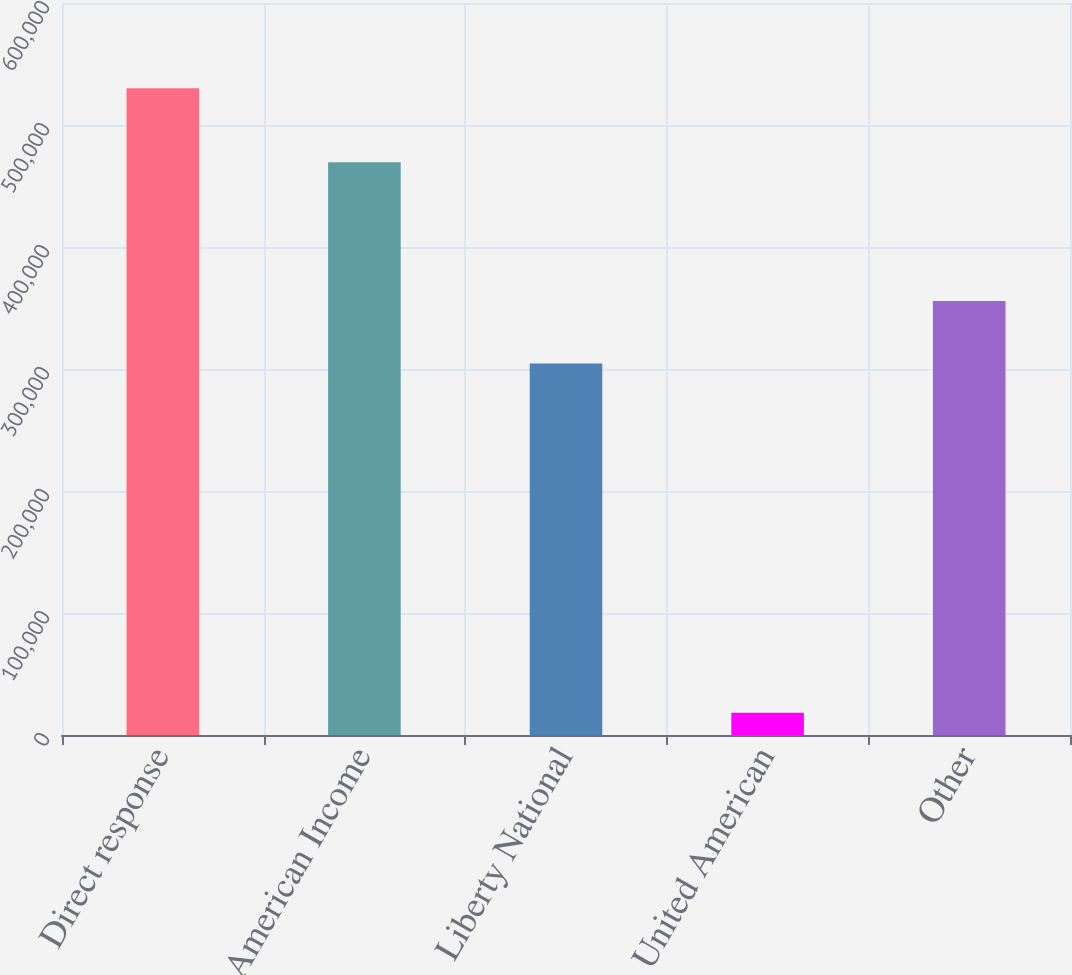<chart> <loc_0><loc_0><loc_500><loc_500><bar_chart><fcel>Direct response<fcel>American Income<fcel>Liberty National<fcel>United American<fcel>Other<nl><fcel>530137<fcel>469486<fcel>304584<fcel>18140<fcel>355784<nl></chart> 